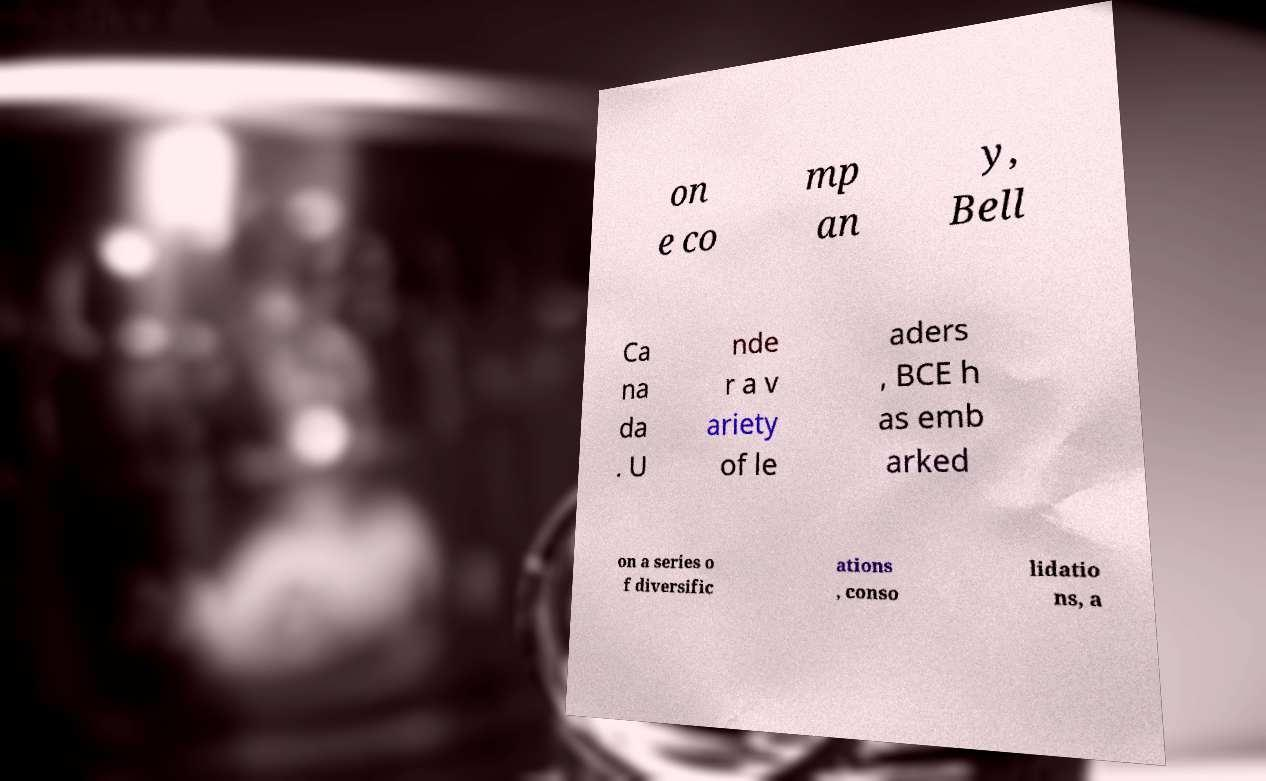Could you assist in decoding the text presented in this image and type it out clearly? on e co mp an y, Bell Ca na da . U nde r a v ariety of le aders , BCE h as emb arked on a series o f diversific ations , conso lidatio ns, a 